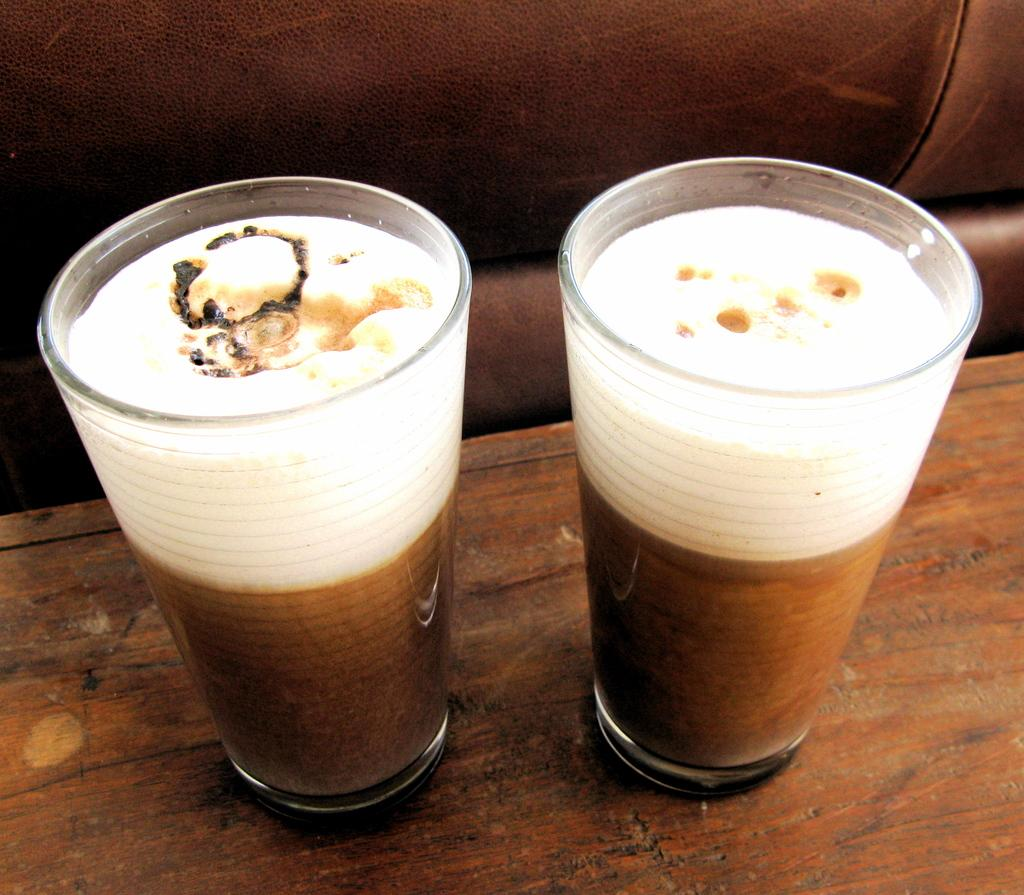What objects are in the foreground of the image? There are two glasses with drinks in the foreground of the image. What is the surface on which the glasses are placed? The glasses are on a wooden surface. What type of furniture can be seen in the background of the image? There is a leather seat in the background of the image. What type of cap is the fish wearing while sitting on the coil in the image? There is no cap, fish, or coil present in the image. 